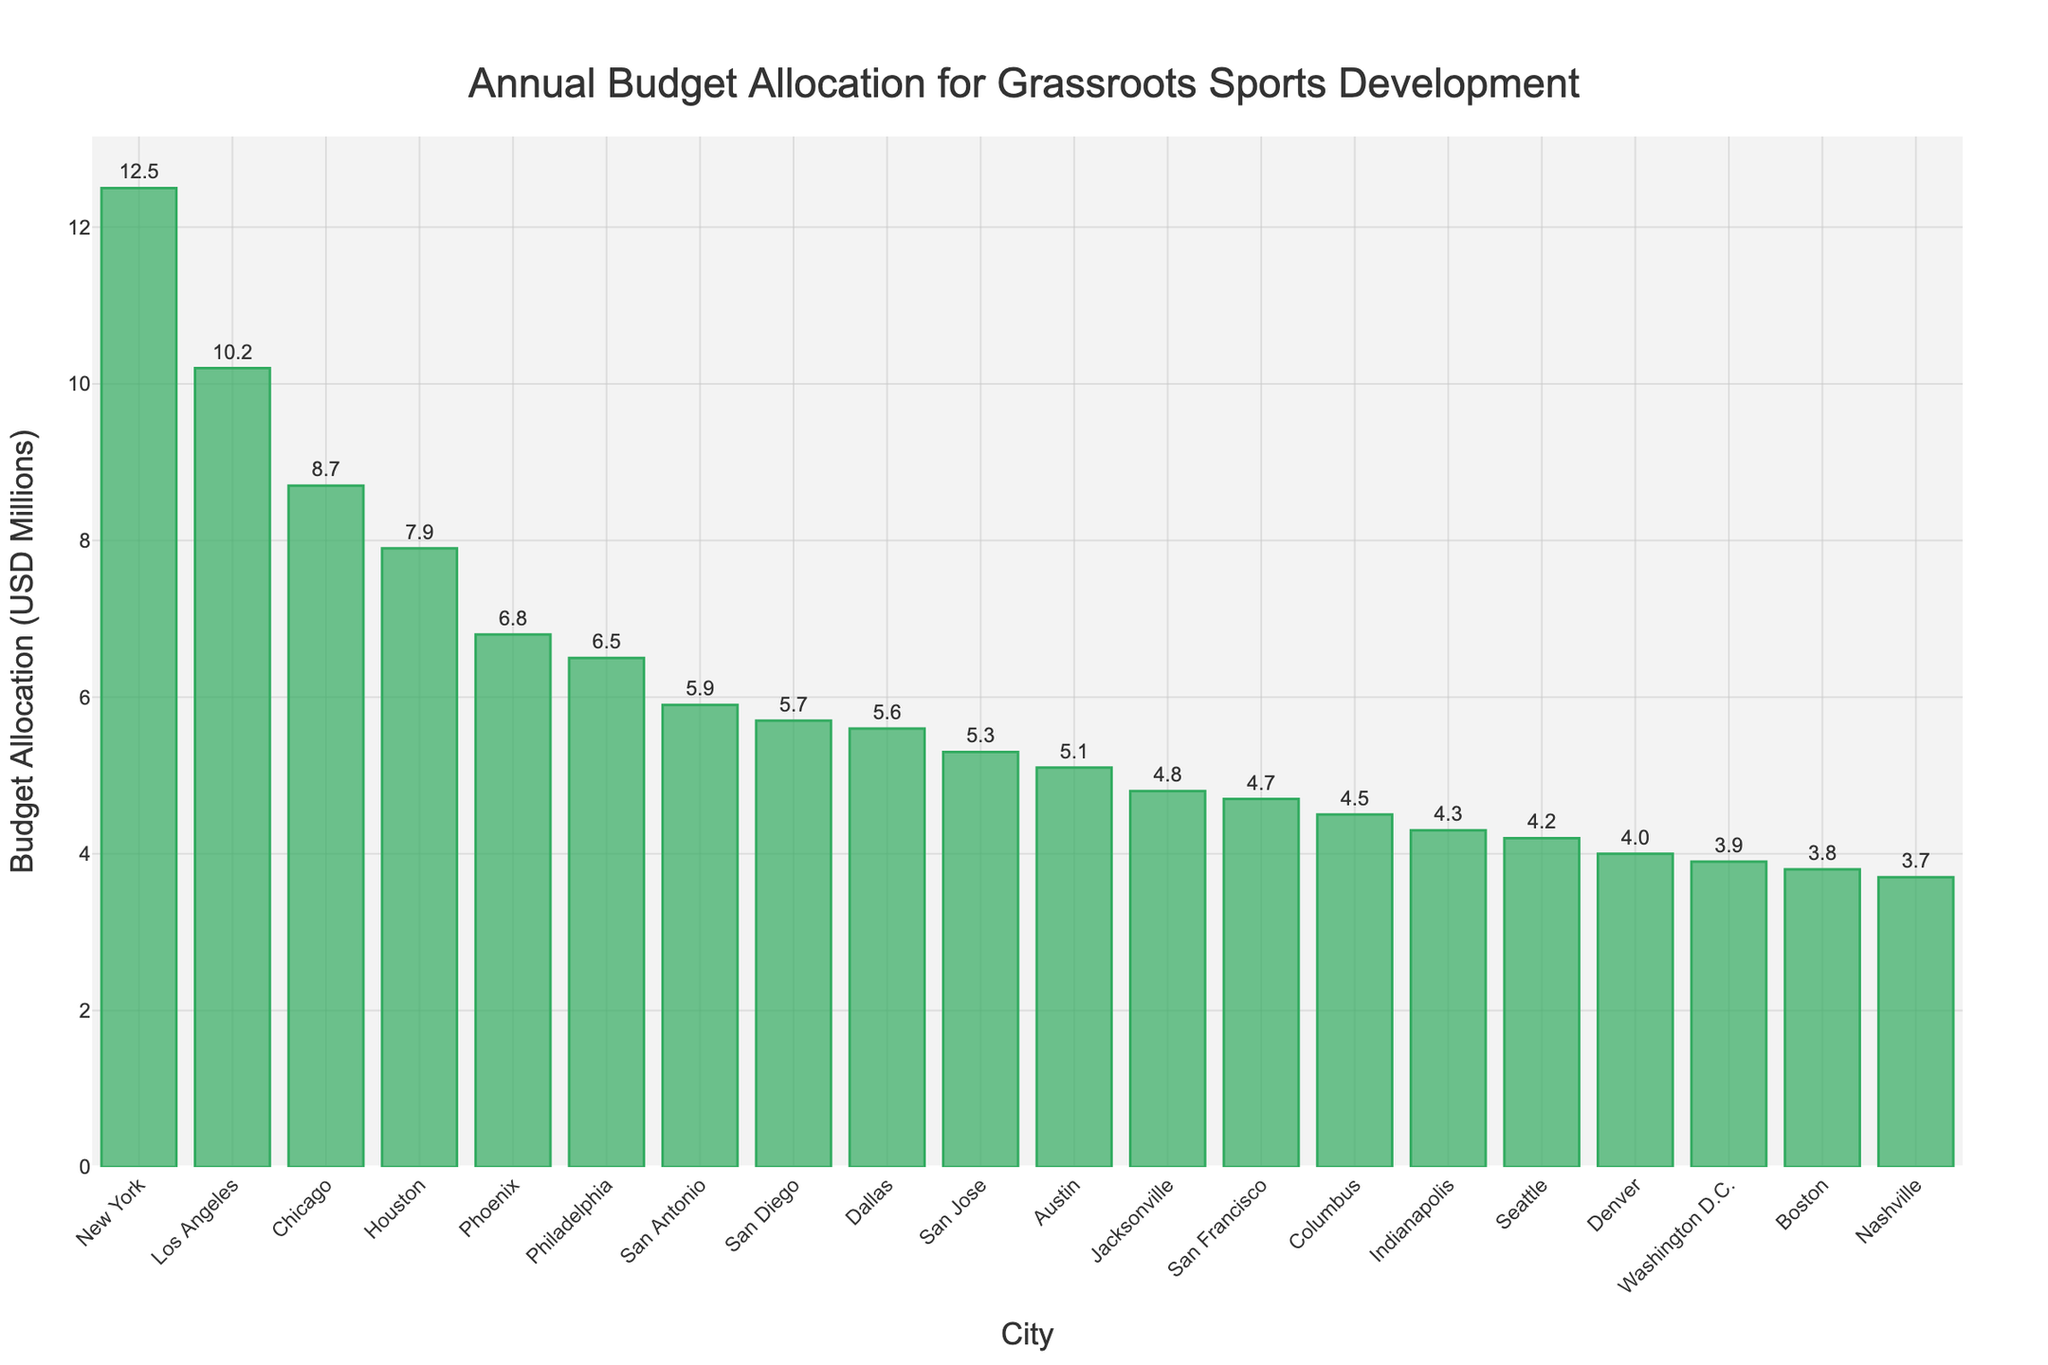Which city has the highest budget allocation for grassroots sports development? To determine the city with the highest budget allocation, look for the tallest bar in the chart. In this case, New York has the tallest bar, indicating the highest budget allocation.
Answer: New York What is the difference in budget allocation between New York and Los Angeles? Identify the heights of the bars for New York (12.5 million) and Los Angeles (10.2 million). Subtract the smaller value from the larger value: 12.5 - 10.2 = 2.3 million.
Answer: 2.3 million How many cities have a budget allocation of less than 5 million? Count the number of bars whose heights correspond to budget allocations under 5 million. These cities are Denver, Washington D.C., Boston, and Nashville. There are 4 such cities.
Answer: 4 What is the total budget allocation for the three cities with the lowest funding? Identify the three cities with the shortest bars (lowest funding): Nashville (3.7 million), Boston (3.8 million), and Washington D.C. (3.9 million). Add their values: 3.7 + 3.8 + 3.9 = 11.4 million.
Answer: 11.4 million Is Houston's budget allocation greater than San Antonio's by more than 2 million? Identify the heights of the bars for Houston (7.9 million) and San Antonio (5.9 million). Calculate the difference: 7.9 - 5.9 = 2 million. Since 2 million is not greater than 2 million, the answer is no.
Answer: No Compare the budget allocation of Philadelphia and Seattle. Which city has a higher allocation? Look at the heights of the bars for Philadelphia (6.5 million) and Seattle (4.2 million). Since 6.5 million is greater than 4.2 million, Philadelphia has a higher allocation.
Answer: Philadelphia What is the average budget allocation for the top 5 cities? Identify the top 5 cities: New York (12.5 million), Los Angeles (10.2 million), Chicago (8.7 million), Houston (7.9 million), and Phoenix (6.8 million). Sum their allocations: 12.5 + 10.2 + 8.7 + 7.9 + 6.8 = 46.1 million. Divide by 5 to find the average: 46.1 / 5 = 9.22 million.
Answer: 9.22 million What is the combined budget allocation for cities with more than 6 million in funding? Identify the cities with over 6 million in funding: New York (12.5 million), Los Angeles (10.2 million), Chicago (8.7 million), Houston (7.9 million), Phoenix (6.8 million), and Philadelphia (6.5 million). Sum their allocations: 12.5 + 10.2 + 8.7 + 7.9 + 6.8 + 6.5 = 52.6 million.
Answer: 52.6 million Which city has a budget closest to the median value? The median value is the middle value in an ordered list. Order the cities' budgets and find the middle value. The median here is the 10th value, as there are 20 cities. The 10th city's budget is Dallas (5.6 million), which is closest to the middle of the sorted list.
Answer: Dallas 